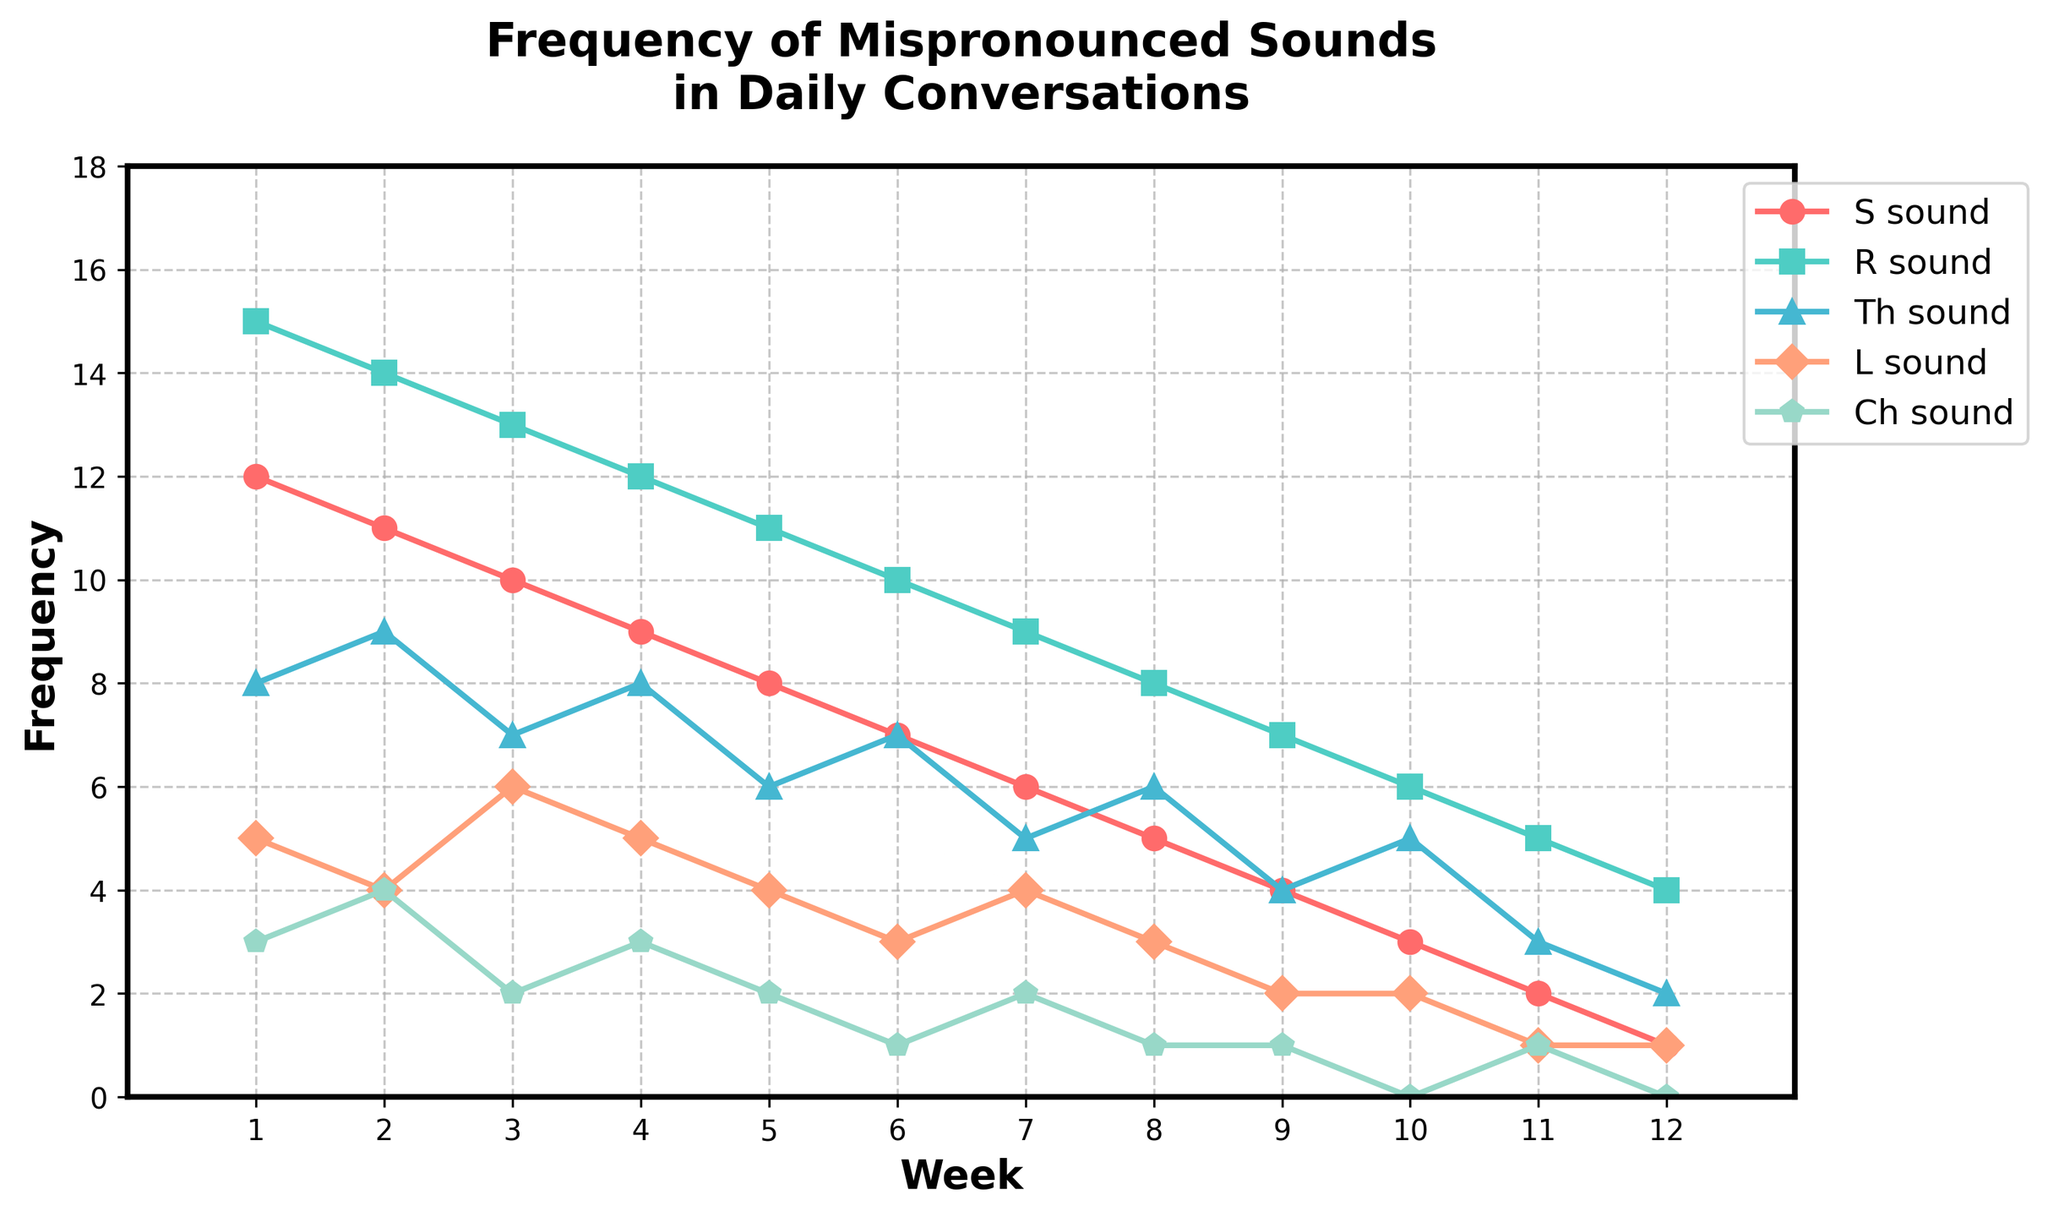What sound had the highest frequency of mispronunciation in Week 1? We look at Week 1 and identify that the R sound had a frequency of 15, which is higher than the S sound (12), Th sound (8), L sound (5), and Ch sound (3).
Answer: R sound How many total mispronunciations were there in Week 5? Sum the frequencies of the mispronounced sounds in Week 5: S (8) + R (11) + Th (6) + L (4) + Ch (2) = 31.
Answer: 31 Which week had the lowest frequency of the Th sound? We look for the lowest point on the Th sound line. The lowest frequency is 2, which occurs in Week 12.
Answer: Week 12 How did the frequency of the S sound change from Week 2 to Week 6? The frequency of the S sound in Week 2 is 11, and in Week 6 it is 7. The change is 11 - 7 = 4.
Answer: Decreased by 4 Between which weeks did the L sound have the most significant drop? The L sound drops from 4 to 3 between Week 6 and Week 7, a change of 1. From Week 5 to Week 6, it drops from 4 to 3, also a change of 1. Therefore, the significant drop can be inferred between Week 5 and Week 6 or Week 6 and Week 7.
Answer: Week 5 and Week 6 or Week 6 and Week 7 What is the overall trend for the Ch sound across all weeks? By observing the Ch sound line, we see that it starts at 3 in Week 1 and ends at 0 in Week 12, with a general downward trend.
Answer: Decreasing Which sound experienced the most significant fluctuation over the 12 weeks? We need to compare the range (maximum value - minimum value) for each sound. The R sound has the largest range from 15 (Week 1) to 4 (Week 12), which is 15 - 4 = 11.
Answer: R sound What is the average frequency of the L sound over the 12 weeks? Sum the frequencies of the L sound and divide by the number of weeks: (5 + 4 + 6 + 5 + 4 + 3 + 4 + 3 + 2 + 2 + 1 + 1) / 12 = 40 / 12 ≈ 3.33.
Answer: 3.33 In which week did the S sound and the Th sound have the same frequency? Find where the S sound line and the Th sound line intersect. They both have a frequency of 5 in Week 10.
Answer: Week 10 